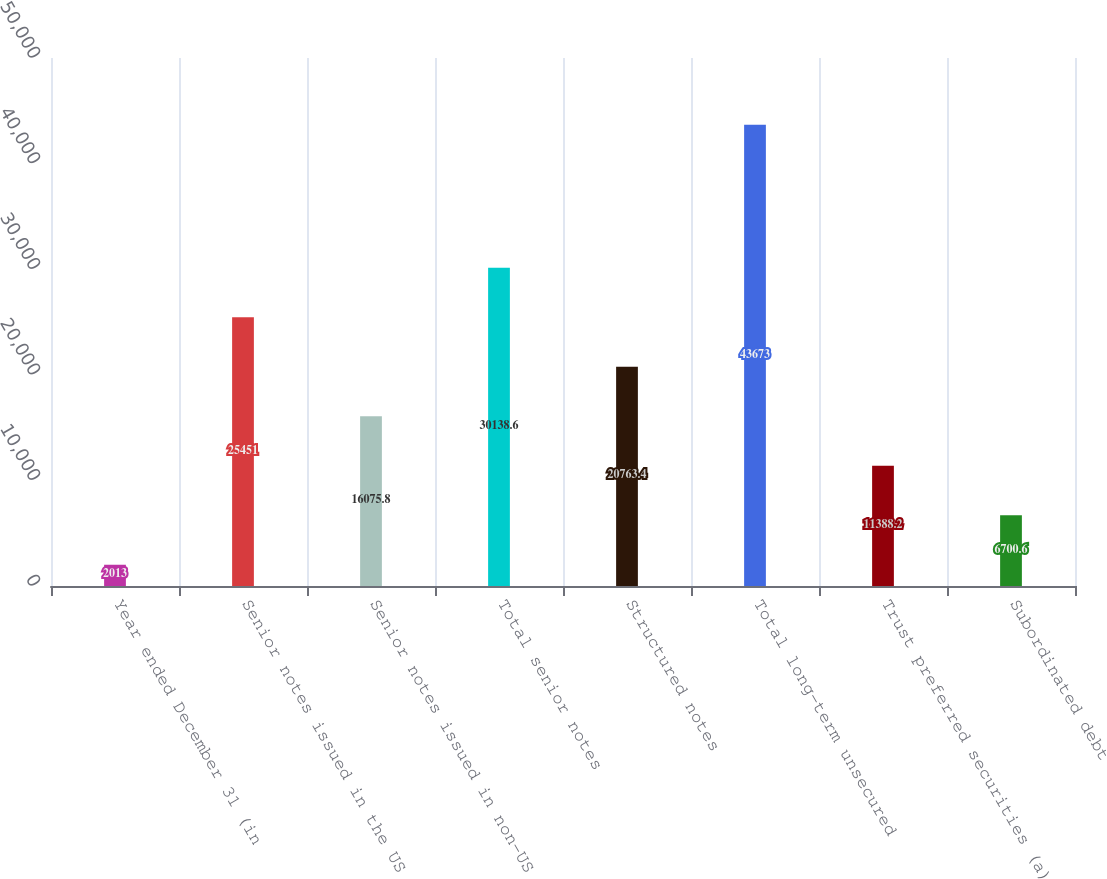Convert chart to OTSL. <chart><loc_0><loc_0><loc_500><loc_500><bar_chart><fcel>Year ended December 31 (in<fcel>Senior notes issued in the US<fcel>Senior notes issued in non-US<fcel>Total senior notes<fcel>Structured notes<fcel>Total long-term unsecured<fcel>Trust preferred securities (a)<fcel>Subordinated debt<nl><fcel>2013<fcel>25451<fcel>16075.8<fcel>30138.6<fcel>20763.4<fcel>43673<fcel>11388.2<fcel>6700.6<nl></chart> 